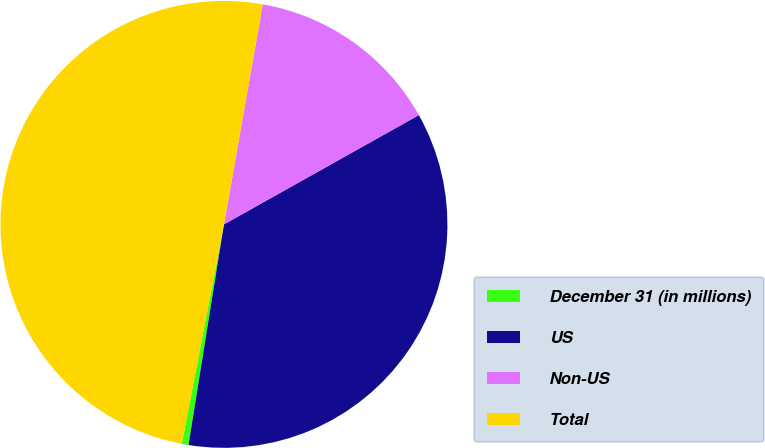Convert chart to OTSL. <chart><loc_0><loc_0><loc_500><loc_500><pie_chart><fcel>December 31 (in millions)<fcel>US<fcel>Non-US<fcel>Total<nl><fcel>0.49%<fcel>35.67%<fcel>14.09%<fcel>49.76%<nl></chart> 